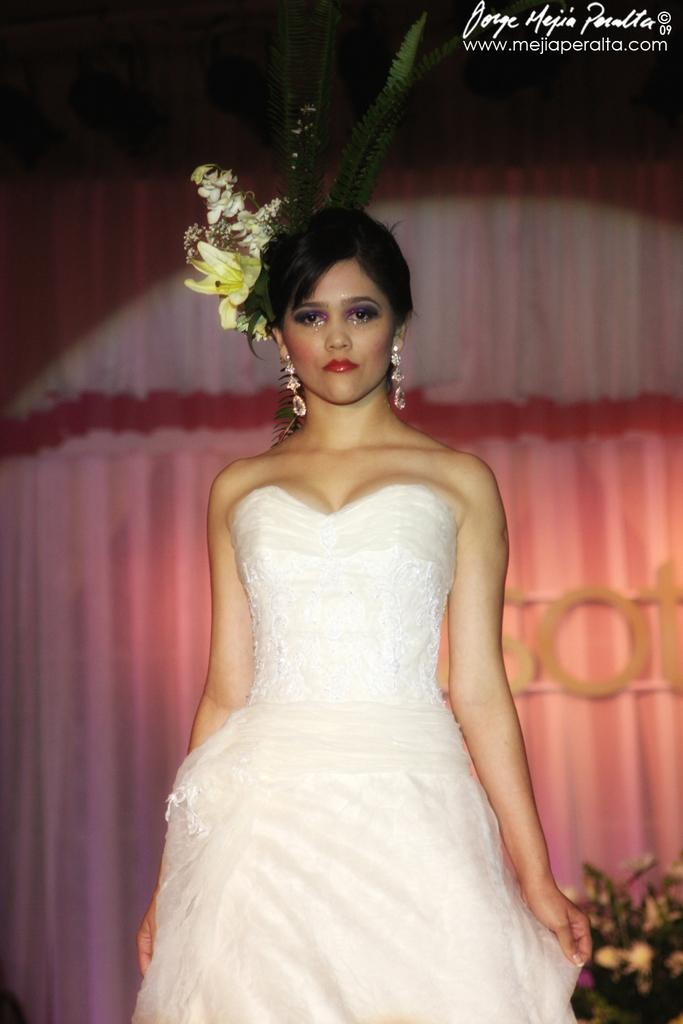Who is present in the image? There is a woman in the image. What is the woman wearing? The woman is wearing a white dress. What can be seen in the background of the image? There is a curtain in the background of the image. What type of beetle can be seen crawling in the woman's pocket in the image? There is no beetle present in the image, and the woman is not shown wearing any pockets. 